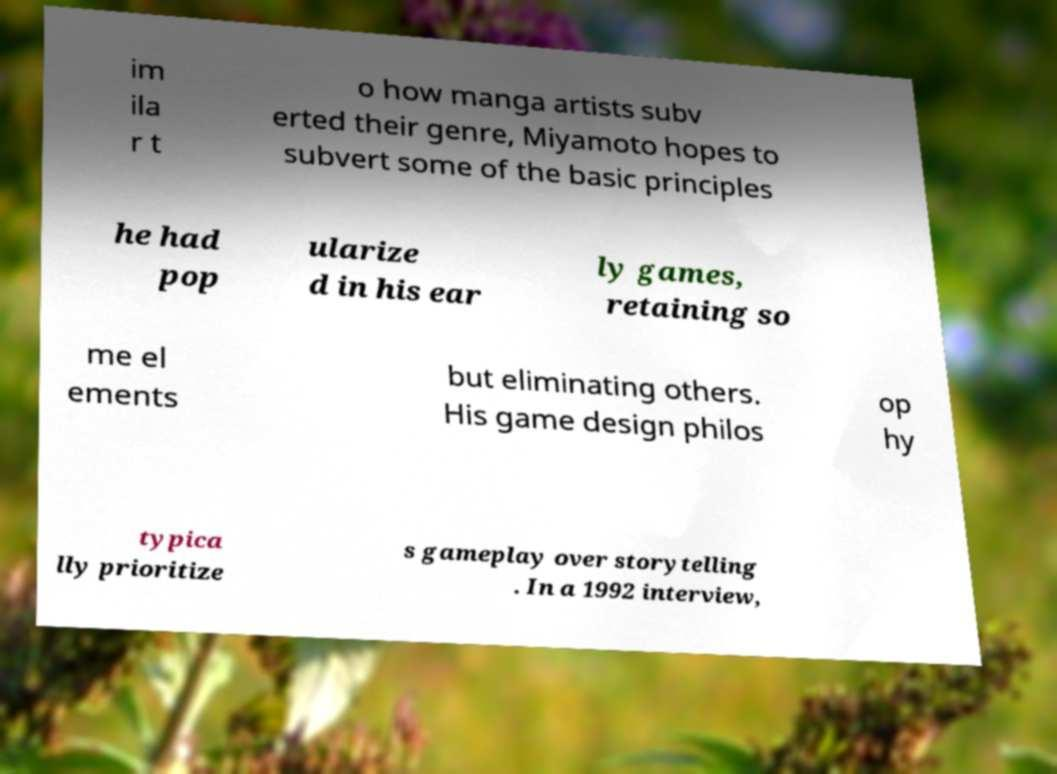Can you read and provide the text displayed in the image?This photo seems to have some interesting text. Can you extract and type it out for me? im ila r t o how manga artists subv erted their genre, Miyamoto hopes to subvert some of the basic principles he had pop ularize d in his ear ly games, retaining so me el ements but eliminating others. His game design philos op hy typica lly prioritize s gameplay over storytelling . In a 1992 interview, 